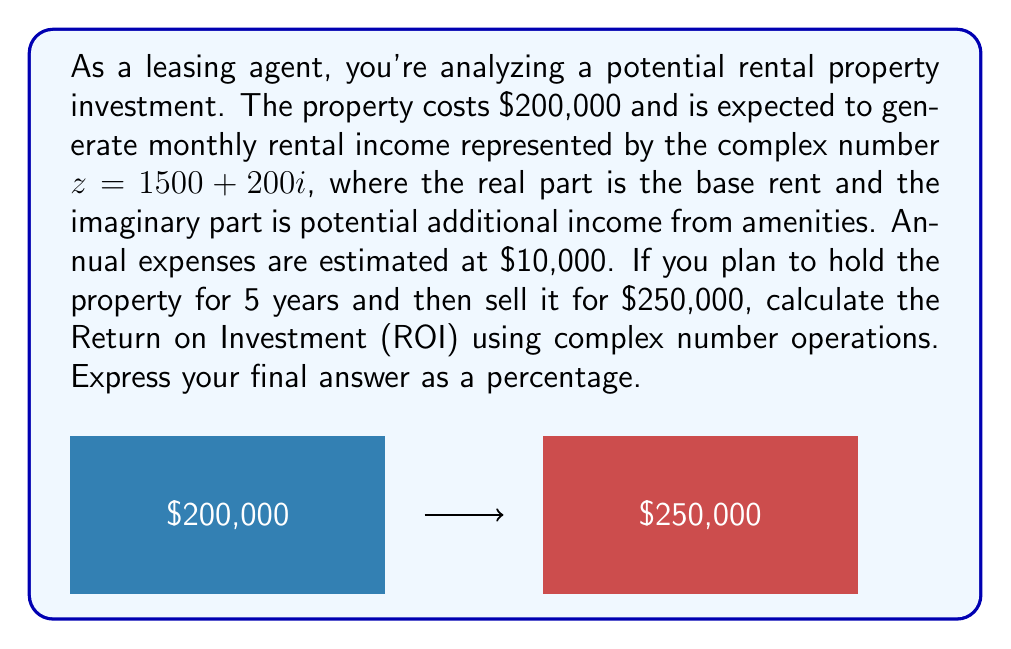Help me with this question. Let's break this down step-by-step:

1) First, let's calculate the annual income using the complex number $z$:
   Annual income = $12 \times (1500 + 200i) = 18000 + 2400i$

2) Net annual income = Annual income - Annual expenses
   $= (18000 + 2400i) - 10000 = 8000 + 2400i$

3) Total income over 5 years:
   $5 \times (8000 + 2400i) = 40000 + 12000i$

4) Add the sale price to the total income:
   Total return = $(40000 + 12000i) + 250000 = 290000 + 12000i$

5) To calculate ROI, we need the magnitude of this complex number:
   $|290000 + 12000i| = \sqrt{290000^2 + 12000^2} = 290249.93$

6) ROI formula: $\text{ROI} = \frac{\text{Net Profit}}{\text{Cost of Investment}} \times 100\%$

   Net Profit = $290249.93 - 200000 = 90249.93$

   $\text{ROI} = \frac{90249.93}{200000} \times 100\% = 45.12\%$
Answer: $45.12\%$ 